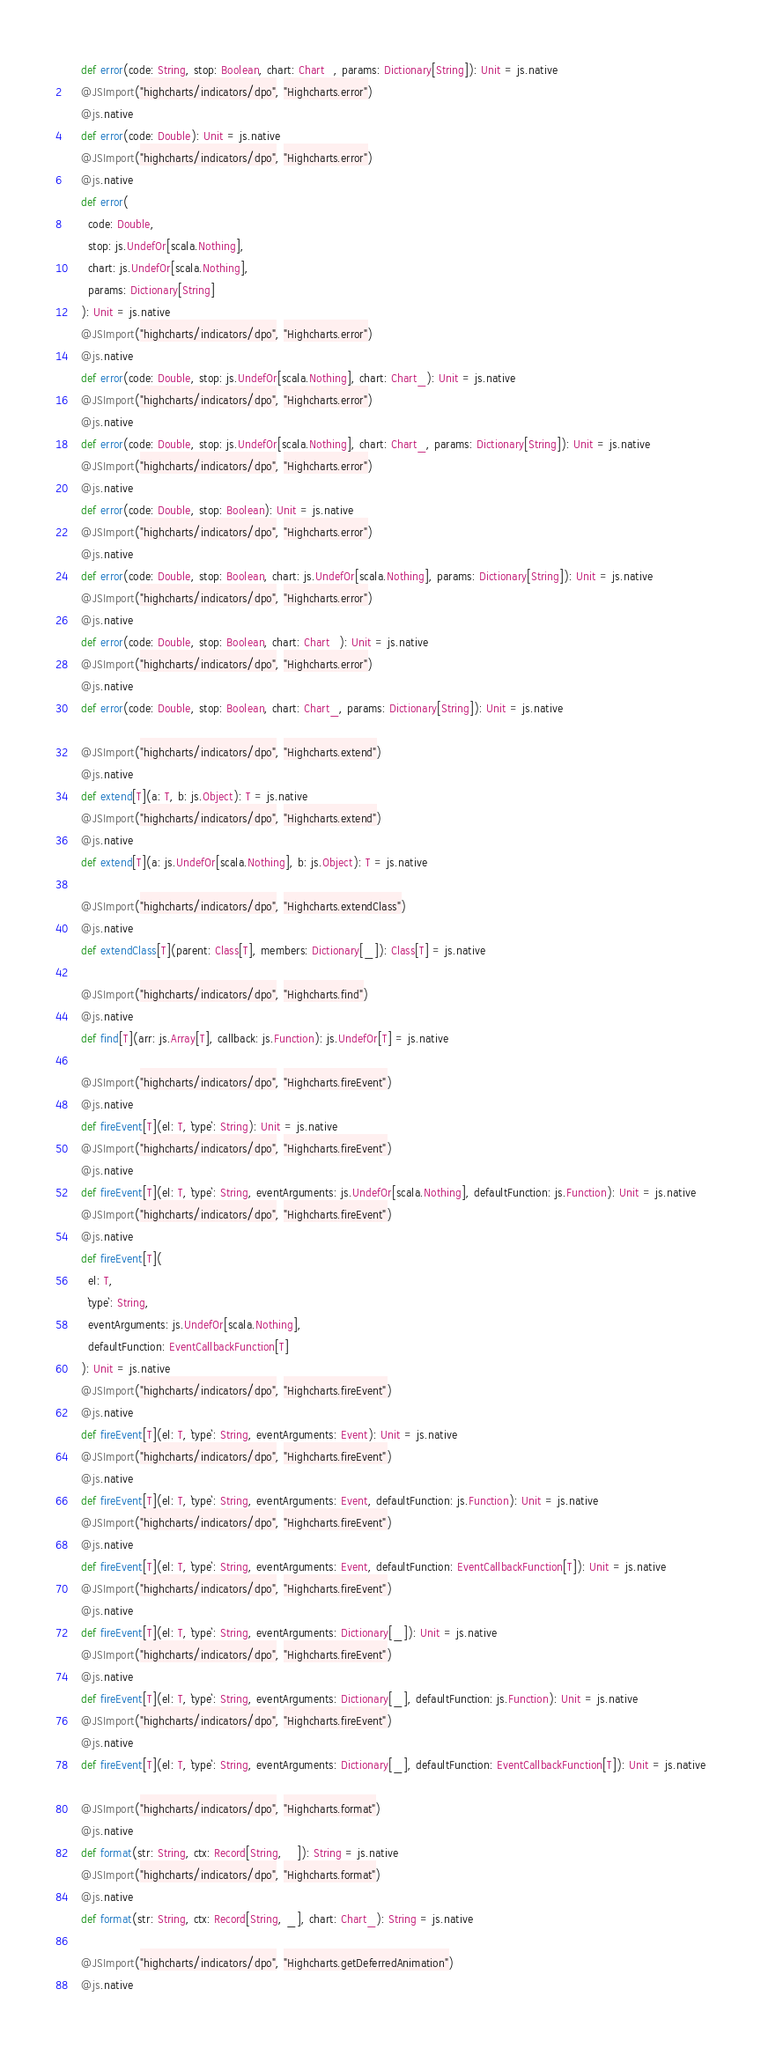Convert code to text. <code><loc_0><loc_0><loc_500><loc_500><_Scala_>    def error(code: String, stop: Boolean, chart: Chart_, params: Dictionary[String]): Unit = js.native
    @JSImport("highcharts/indicators/dpo", "Highcharts.error")
    @js.native
    def error(code: Double): Unit = js.native
    @JSImport("highcharts/indicators/dpo", "Highcharts.error")
    @js.native
    def error(
      code: Double,
      stop: js.UndefOr[scala.Nothing],
      chart: js.UndefOr[scala.Nothing],
      params: Dictionary[String]
    ): Unit = js.native
    @JSImport("highcharts/indicators/dpo", "Highcharts.error")
    @js.native
    def error(code: Double, stop: js.UndefOr[scala.Nothing], chart: Chart_): Unit = js.native
    @JSImport("highcharts/indicators/dpo", "Highcharts.error")
    @js.native
    def error(code: Double, stop: js.UndefOr[scala.Nothing], chart: Chart_, params: Dictionary[String]): Unit = js.native
    @JSImport("highcharts/indicators/dpo", "Highcharts.error")
    @js.native
    def error(code: Double, stop: Boolean): Unit = js.native
    @JSImport("highcharts/indicators/dpo", "Highcharts.error")
    @js.native
    def error(code: Double, stop: Boolean, chart: js.UndefOr[scala.Nothing], params: Dictionary[String]): Unit = js.native
    @JSImport("highcharts/indicators/dpo", "Highcharts.error")
    @js.native
    def error(code: Double, stop: Boolean, chart: Chart_): Unit = js.native
    @JSImport("highcharts/indicators/dpo", "Highcharts.error")
    @js.native
    def error(code: Double, stop: Boolean, chart: Chart_, params: Dictionary[String]): Unit = js.native
    
    @JSImport("highcharts/indicators/dpo", "Highcharts.extend")
    @js.native
    def extend[T](a: T, b: js.Object): T = js.native
    @JSImport("highcharts/indicators/dpo", "Highcharts.extend")
    @js.native
    def extend[T](a: js.UndefOr[scala.Nothing], b: js.Object): T = js.native
    
    @JSImport("highcharts/indicators/dpo", "Highcharts.extendClass")
    @js.native
    def extendClass[T](parent: Class[T], members: Dictionary[_]): Class[T] = js.native
    
    @JSImport("highcharts/indicators/dpo", "Highcharts.find")
    @js.native
    def find[T](arr: js.Array[T], callback: js.Function): js.UndefOr[T] = js.native
    
    @JSImport("highcharts/indicators/dpo", "Highcharts.fireEvent")
    @js.native
    def fireEvent[T](el: T, `type`: String): Unit = js.native
    @JSImport("highcharts/indicators/dpo", "Highcharts.fireEvent")
    @js.native
    def fireEvent[T](el: T, `type`: String, eventArguments: js.UndefOr[scala.Nothing], defaultFunction: js.Function): Unit = js.native
    @JSImport("highcharts/indicators/dpo", "Highcharts.fireEvent")
    @js.native
    def fireEvent[T](
      el: T,
      `type`: String,
      eventArguments: js.UndefOr[scala.Nothing],
      defaultFunction: EventCallbackFunction[T]
    ): Unit = js.native
    @JSImport("highcharts/indicators/dpo", "Highcharts.fireEvent")
    @js.native
    def fireEvent[T](el: T, `type`: String, eventArguments: Event): Unit = js.native
    @JSImport("highcharts/indicators/dpo", "Highcharts.fireEvent")
    @js.native
    def fireEvent[T](el: T, `type`: String, eventArguments: Event, defaultFunction: js.Function): Unit = js.native
    @JSImport("highcharts/indicators/dpo", "Highcharts.fireEvent")
    @js.native
    def fireEvent[T](el: T, `type`: String, eventArguments: Event, defaultFunction: EventCallbackFunction[T]): Unit = js.native
    @JSImport("highcharts/indicators/dpo", "Highcharts.fireEvent")
    @js.native
    def fireEvent[T](el: T, `type`: String, eventArguments: Dictionary[_]): Unit = js.native
    @JSImport("highcharts/indicators/dpo", "Highcharts.fireEvent")
    @js.native
    def fireEvent[T](el: T, `type`: String, eventArguments: Dictionary[_], defaultFunction: js.Function): Unit = js.native
    @JSImport("highcharts/indicators/dpo", "Highcharts.fireEvent")
    @js.native
    def fireEvent[T](el: T, `type`: String, eventArguments: Dictionary[_], defaultFunction: EventCallbackFunction[T]): Unit = js.native
    
    @JSImport("highcharts/indicators/dpo", "Highcharts.format")
    @js.native
    def format(str: String, ctx: Record[String, _]): String = js.native
    @JSImport("highcharts/indicators/dpo", "Highcharts.format")
    @js.native
    def format(str: String, ctx: Record[String, _], chart: Chart_): String = js.native
    
    @JSImport("highcharts/indicators/dpo", "Highcharts.getDeferredAnimation")
    @js.native</code> 